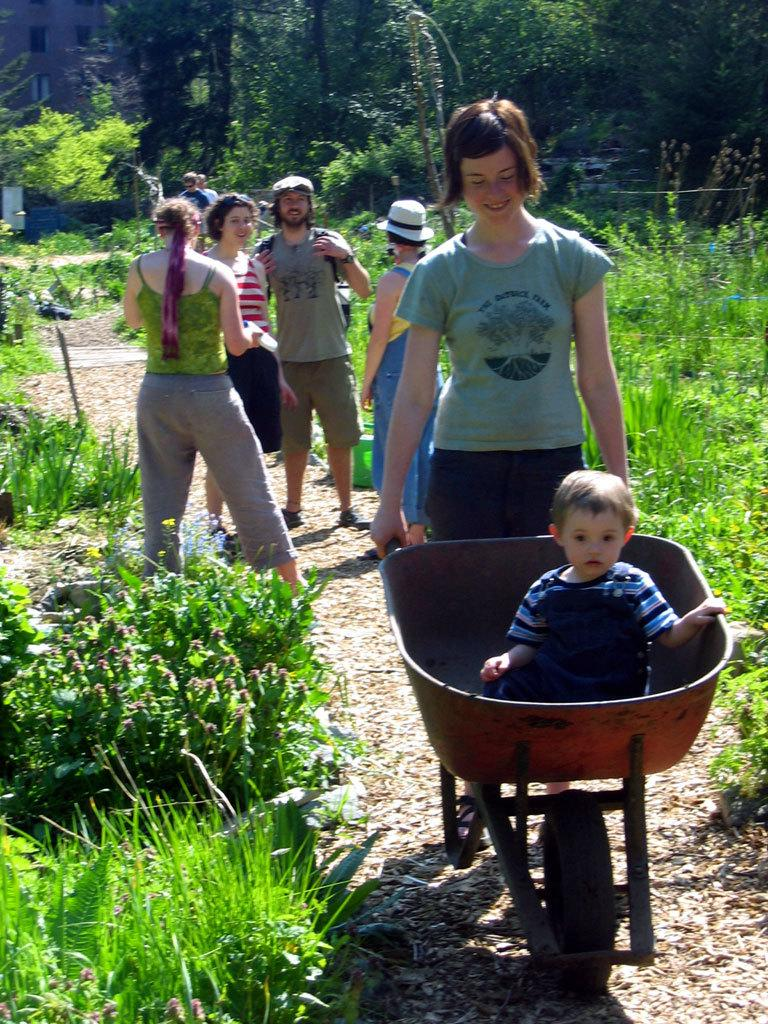What is happening in the path in the image? There are people in the path in the image. What is the kid doing in the image? The kid is sitting in a trolley. What type of vegetation is present on the ground? There are plants and grass on the ground. What can be seen in the background of the image? There are trees in the background of the image. How many flowers are in the front of the image? There are no flowers mentioned or visible in the image. 